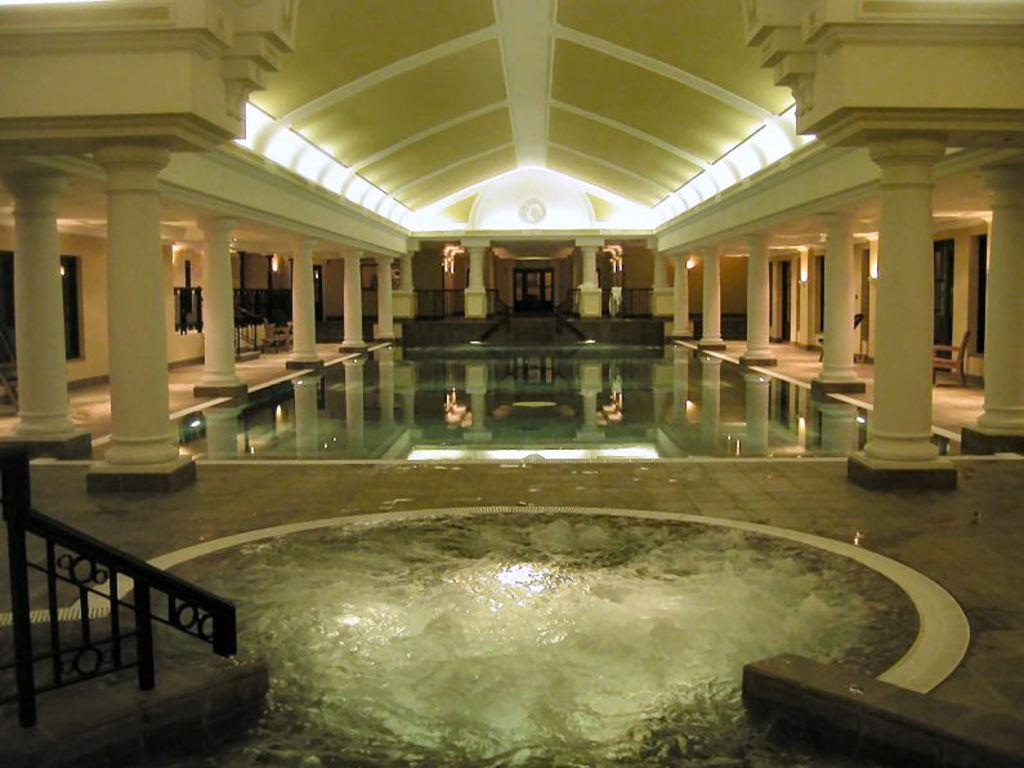What is located in the middle of the image? There is water in the middle of the image. What can be seen at the top of the image? There are lights visible at the top of the image. What type of furniture is on the right side of the image? There are chairs on the right side of the image. How many clovers are growing in the water in the image? There are no clovers present in the image; it features water in the middle. What emotion does the image evoke in the viewer? The image itself does not evoke any specific emotion, as it is a neutral representation of water, lights, and chairs. 